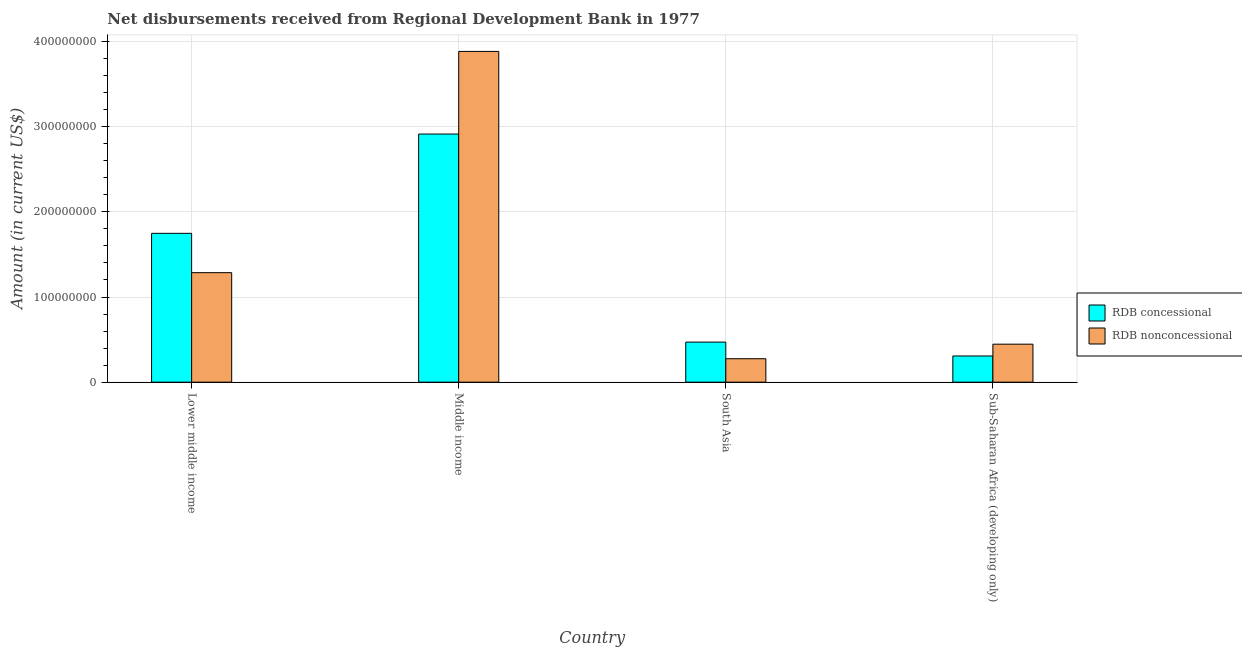How many groups of bars are there?
Offer a very short reply. 4. Are the number of bars per tick equal to the number of legend labels?
Make the answer very short. Yes. How many bars are there on the 4th tick from the left?
Offer a terse response. 2. How many bars are there on the 1st tick from the right?
Provide a short and direct response. 2. What is the label of the 4th group of bars from the left?
Keep it short and to the point. Sub-Saharan Africa (developing only). In how many cases, is the number of bars for a given country not equal to the number of legend labels?
Offer a very short reply. 0. What is the net concessional disbursements from rdb in Lower middle income?
Offer a terse response. 1.75e+08. Across all countries, what is the maximum net concessional disbursements from rdb?
Provide a short and direct response. 2.91e+08. Across all countries, what is the minimum net concessional disbursements from rdb?
Make the answer very short. 3.08e+07. In which country was the net non concessional disbursements from rdb maximum?
Provide a short and direct response. Middle income. In which country was the net non concessional disbursements from rdb minimum?
Keep it short and to the point. South Asia. What is the total net non concessional disbursements from rdb in the graph?
Your answer should be compact. 5.89e+08. What is the difference between the net concessional disbursements from rdb in South Asia and that in Sub-Saharan Africa (developing only)?
Provide a short and direct response. 1.63e+07. What is the difference between the net non concessional disbursements from rdb in Sub-Saharan Africa (developing only) and the net concessional disbursements from rdb in South Asia?
Your answer should be compact. -2.44e+06. What is the average net concessional disbursements from rdb per country?
Keep it short and to the point. 1.36e+08. What is the difference between the net non concessional disbursements from rdb and net concessional disbursements from rdb in Middle income?
Your answer should be compact. 9.71e+07. What is the ratio of the net non concessional disbursements from rdb in South Asia to that in Sub-Saharan Africa (developing only)?
Your response must be concise. 0.62. Is the net non concessional disbursements from rdb in Lower middle income less than that in Sub-Saharan Africa (developing only)?
Offer a terse response. No. Is the difference between the net concessional disbursements from rdb in Lower middle income and Middle income greater than the difference between the net non concessional disbursements from rdb in Lower middle income and Middle income?
Your answer should be very brief. Yes. What is the difference between the highest and the second highest net concessional disbursements from rdb?
Offer a very short reply. 1.17e+08. What is the difference between the highest and the lowest net non concessional disbursements from rdb?
Provide a short and direct response. 3.61e+08. In how many countries, is the net non concessional disbursements from rdb greater than the average net non concessional disbursements from rdb taken over all countries?
Keep it short and to the point. 1. Is the sum of the net concessional disbursements from rdb in Lower middle income and Middle income greater than the maximum net non concessional disbursements from rdb across all countries?
Make the answer very short. Yes. What does the 1st bar from the left in Sub-Saharan Africa (developing only) represents?
Ensure brevity in your answer.  RDB concessional. What does the 2nd bar from the right in Sub-Saharan Africa (developing only) represents?
Give a very brief answer. RDB concessional. How many bars are there?
Your response must be concise. 8. How many countries are there in the graph?
Make the answer very short. 4. How are the legend labels stacked?
Provide a succinct answer. Vertical. What is the title of the graph?
Your answer should be very brief. Net disbursements received from Regional Development Bank in 1977. Does "Electricity and heat production" appear as one of the legend labels in the graph?
Give a very brief answer. No. What is the Amount (in current US$) in RDB concessional in Lower middle income?
Provide a short and direct response. 1.75e+08. What is the Amount (in current US$) in RDB nonconcessional in Lower middle income?
Offer a very short reply. 1.29e+08. What is the Amount (in current US$) in RDB concessional in Middle income?
Make the answer very short. 2.91e+08. What is the Amount (in current US$) in RDB nonconcessional in Middle income?
Make the answer very short. 3.89e+08. What is the Amount (in current US$) in RDB concessional in South Asia?
Ensure brevity in your answer.  4.70e+07. What is the Amount (in current US$) of RDB nonconcessional in South Asia?
Offer a terse response. 2.75e+07. What is the Amount (in current US$) of RDB concessional in Sub-Saharan Africa (developing only)?
Make the answer very short. 3.08e+07. What is the Amount (in current US$) in RDB nonconcessional in Sub-Saharan Africa (developing only)?
Your answer should be compact. 4.46e+07. Across all countries, what is the maximum Amount (in current US$) of RDB concessional?
Ensure brevity in your answer.  2.91e+08. Across all countries, what is the maximum Amount (in current US$) in RDB nonconcessional?
Your answer should be very brief. 3.89e+08. Across all countries, what is the minimum Amount (in current US$) in RDB concessional?
Your response must be concise. 3.08e+07. Across all countries, what is the minimum Amount (in current US$) of RDB nonconcessional?
Your answer should be very brief. 2.75e+07. What is the total Amount (in current US$) of RDB concessional in the graph?
Ensure brevity in your answer.  5.44e+08. What is the total Amount (in current US$) in RDB nonconcessional in the graph?
Your answer should be compact. 5.89e+08. What is the difference between the Amount (in current US$) of RDB concessional in Lower middle income and that in Middle income?
Your answer should be compact. -1.17e+08. What is the difference between the Amount (in current US$) of RDB nonconcessional in Lower middle income and that in Middle income?
Your answer should be compact. -2.60e+08. What is the difference between the Amount (in current US$) in RDB concessional in Lower middle income and that in South Asia?
Keep it short and to the point. 1.28e+08. What is the difference between the Amount (in current US$) in RDB nonconcessional in Lower middle income and that in South Asia?
Your response must be concise. 1.01e+08. What is the difference between the Amount (in current US$) of RDB concessional in Lower middle income and that in Sub-Saharan Africa (developing only)?
Your answer should be compact. 1.44e+08. What is the difference between the Amount (in current US$) of RDB nonconcessional in Lower middle income and that in Sub-Saharan Africa (developing only)?
Keep it short and to the point. 8.40e+07. What is the difference between the Amount (in current US$) in RDB concessional in Middle income and that in South Asia?
Your answer should be compact. 2.44e+08. What is the difference between the Amount (in current US$) in RDB nonconcessional in Middle income and that in South Asia?
Make the answer very short. 3.61e+08. What is the difference between the Amount (in current US$) of RDB concessional in Middle income and that in Sub-Saharan Africa (developing only)?
Provide a succinct answer. 2.61e+08. What is the difference between the Amount (in current US$) of RDB nonconcessional in Middle income and that in Sub-Saharan Africa (developing only)?
Ensure brevity in your answer.  3.44e+08. What is the difference between the Amount (in current US$) in RDB concessional in South Asia and that in Sub-Saharan Africa (developing only)?
Provide a succinct answer. 1.63e+07. What is the difference between the Amount (in current US$) of RDB nonconcessional in South Asia and that in Sub-Saharan Africa (developing only)?
Provide a succinct answer. -1.71e+07. What is the difference between the Amount (in current US$) of RDB concessional in Lower middle income and the Amount (in current US$) of RDB nonconcessional in Middle income?
Offer a terse response. -2.14e+08. What is the difference between the Amount (in current US$) in RDB concessional in Lower middle income and the Amount (in current US$) in RDB nonconcessional in South Asia?
Offer a terse response. 1.47e+08. What is the difference between the Amount (in current US$) of RDB concessional in Lower middle income and the Amount (in current US$) of RDB nonconcessional in Sub-Saharan Africa (developing only)?
Provide a succinct answer. 1.30e+08. What is the difference between the Amount (in current US$) of RDB concessional in Middle income and the Amount (in current US$) of RDB nonconcessional in South Asia?
Keep it short and to the point. 2.64e+08. What is the difference between the Amount (in current US$) of RDB concessional in Middle income and the Amount (in current US$) of RDB nonconcessional in Sub-Saharan Africa (developing only)?
Make the answer very short. 2.47e+08. What is the difference between the Amount (in current US$) of RDB concessional in South Asia and the Amount (in current US$) of RDB nonconcessional in Sub-Saharan Africa (developing only)?
Provide a short and direct response. 2.44e+06. What is the average Amount (in current US$) of RDB concessional per country?
Make the answer very short. 1.36e+08. What is the average Amount (in current US$) of RDB nonconcessional per country?
Keep it short and to the point. 1.47e+08. What is the difference between the Amount (in current US$) of RDB concessional and Amount (in current US$) of RDB nonconcessional in Lower middle income?
Your response must be concise. 4.62e+07. What is the difference between the Amount (in current US$) of RDB concessional and Amount (in current US$) of RDB nonconcessional in Middle income?
Provide a short and direct response. -9.71e+07. What is the difference between the Amount (in current US$) in RDB concessional and Amount (in current US$) in RDB nonconcessional in South Asia?
Offer a very short reply. 1.95e+07. What is the difference between the Amount (in current US$) in RDB concessional and Amount (in current US$) in RDB nonconcessional in Sub-Saharan Africa (developing only)?
Your answer should be very brief. -1.39e+07. What is the ratio of the Amount (in current US$) in RDB concessional in Lower middle income to that in Middle income?
Offer a very short reply. 0.6. What is the ratio of the Amount (in current US$) in RDB nonconcessional in Lower middle income to that in Middle income?
Offer a terse response. 0.33. What is the ratio of the Amount (in current US$) of RDB concessional in Lower middle income to that in South Asia?
Make the answer very short. 3.72. What is the ratio of the Amount (in current US$) in RDB nonconcessional in Lower middle income to that in South Asia?
Provide a short and direct response. 4.67. What is the ratio of the Amount (in current US$) in RDB concessional in Lower middle income to that in Sub-Saharan Africa (developing only)?
Give a very brief answer. 5.68. What is the ratio of the Amount (in current US$) of RDB nonconcessional in Lower middle income to that in Sub-Saharan Africa (developing only)?
Keep it short and to the point. 2.88. What is the ratio of the Amount (in current US$) of RDB concessional in Middle income to that in South Asia?
Provide a succinct answer. 6.2. What is the ratio of the Amount (in current US$) in RDB nonconcessional in Middle income to that in South Asia?
Your answer should be compact. 14.12. What is the ratio of the Amount (in current US$) in RDB concessional in Middle income to that in Sub-Saharan Africa (developing only)?
Your answer should be compact. 9.48. What is the ratio of the Amount (in current US$) in RDB nonconcessional in Middle income to that in Sub-Saharan Africa (developing only)?
Your answer should be compact. 8.71. What is the ratio of the Amount (in current US$) in RDB concessional in South Asia to that in Sub-Saharan Africa (developing only)?
Your response must be concise. 1.53. What is the ratio of the Amount (in current US$) of RDB nonconcessional in South Asia to that in Sub-Saharan Africa (developing only)?
Provide a short and direct response. 0.62. What is the difference between the highest and the second highest Amount (in current US$) in RDB concessional?
Provide a succinct answer. 1.17e+08. What is the difference between the highest and the second highest Amount (in current US$) in RDB nonconcessional?
Offer a very short reply. 2.60e+08. What is the difference between the highest and the lowest Amount (in current US$) in RDB concessional?
Your answer should be compact. 2.61e+08. What is the difference between the highest and the lowest Amount (in current US$) in RDB nonconcessional?
Give a very brief answer. 3.61e+08. 